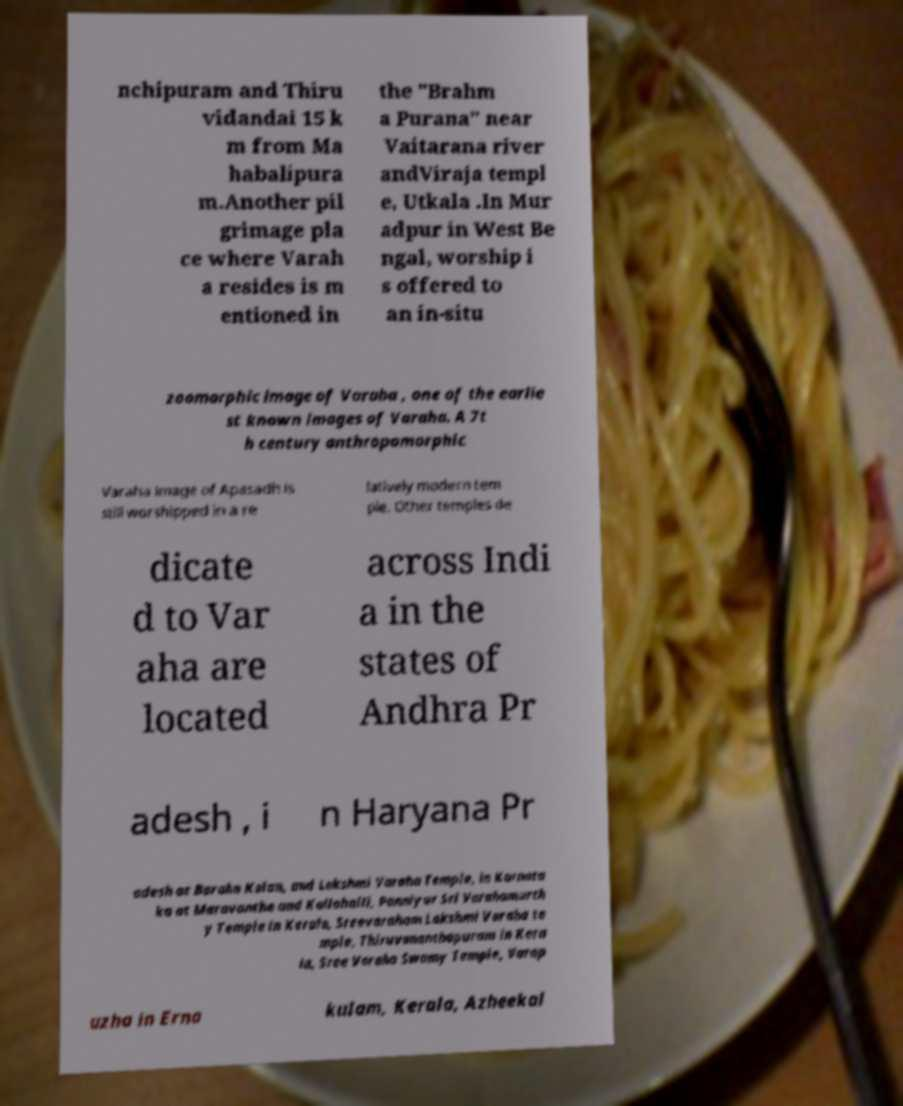For documentation purposes, I need the text within this image transcribed. Could you provide that? nchipuram and Thiru vidandai 15 k m from Ma habalipura m.Another pil grimage pla ce where Varah a resides is m entioned in the "Brahm a Purana" near Vaitarana river andViraja templ e, Utkala .In Mur adpur in West Be ngal, worship i s offered to an in-situ zoomorphic image of Varaha , one of the earlie st known images of Varaha. A 7t h century anthropomorphic Varaha image of Apasadh is still worshipped in a re latively modern tem ple. Other temples de dicate d to Var aha are located across Indi a in the states of Andhra Pr adesh , i n Haryana Pr adesh at Baraha Kalan, and Lakshmi Varaha Temple, in Karnata ka at Maravanthe and Kallahalli, Panniyur Sri Varahamurth y Temple in Kerala, Sreevaraham Lakshmi Varaha te mple, Thiruvananthapuram in Kera la, Sree Varaha Swamy Temple, Varap uzha in Erna kulam, Kerala, Azheekal 